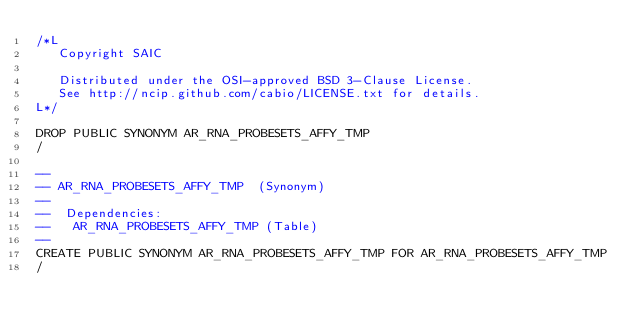<code> <loc_0><loc_0><loc_500><loc_500><_SQL_>/*L
   Copyright SAIC

   Distributed under the OSI-approved BSD 3-Clause License.
   See http://ncip.github.com/cabio/LICENSE.txt for details.
L*/

DROP PUBLIC SYNONYM AR_RNA_PROBESETS_AFFY_TMP
/

--
-- AR_RNA_PROBESETS_AFFY_TMP  (Synonym) 
--
--  Dependencies: 
--   AR_RNA_PROBESETS_AFFY_TMP (Table)
--
CREATE PUBLIC SYNONYM AR_RNA_PROBESETS_AFFY_TMP FOR AR_RNA_PROBESETS_AFFY_TMP
/


</code> 